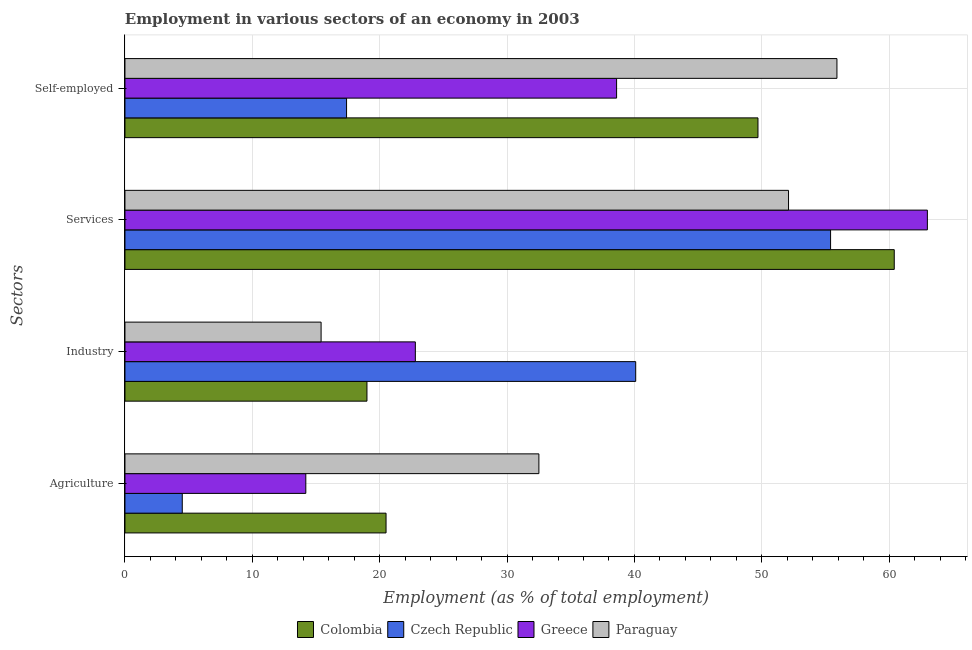Are the number of bars on each tick of the Y-axis equal?
Offer a terse response. Yes. How many bars are there on the 3rd tick from the bottom?
Give a very brief answer. 4. What is the label of the 3rd group of bars from the top?
Your answer should be compact. Industry. What is the percentage of self employed workers in Colombia?
Your answer should be very brief. 49.7. Across all countries, what is the maximum percentage of workers in agriculture?
Give a very brief answer. 32.5. Across all countries, what is the minimum percentage of workers in services?
Your answer should be very brief. 52.1. In which country was the percentage of workers in industry minimum?
Provide a short and direct response. Paraguay. What is the total percentage of workers in agriculture in the graph?
Your answer should be compact. 71.7. What is the difference between the percentage of workers in industry in Colombia and that in Paraguay?
Your answer should be very brief. 3.6. What is the difference between the percentage of workers in agriculture in Colombia and the percentage of workers in industry in Czech Republic?
Make the answer very short. -19.6. What is the average percentage of self employed workers per country?
Give a very brief answer. 40.4. What is the difference between the percentage of self employed workers and percentage of workers in agriculture in Czech Republic?
Offer a terse response. 12.9. In how many countries, is the percentage of workers in industry greater than 50 %?
Your answer should be very brief. 0. What is the ratio of the percentage of workers in agriculture in Czech Republic to that in Paraguay?
Provide a succinct answer. 0.14. Is the percentage of self employed workers in Paraguay less than that in Czech Republic?
Keep it short and to the point. No. What is the difference between the highest and the second highest percentage of self employed workers?
Ensure brevity in your answer.  6.2. What is the difference between the highest and the lowest percentage of workers in services?
Give a very brief answer. 10.9. Is it the case that in every country, the sum of the percentage of workers in services and percentage of workers in industry is greater than the sum of percentage of self employed workers and percentage of workers in agriculture?
Make the answer very short. Yes. What does the 3rd bar from the top in Agriculture represents?
Your answer should be very brief. Czech Republic. What does the 4th bar from the bottom in Agriculture represents?
Your answer should be compact. Paraguay. Is it the case that in every country, the sum of the percentage of workers in agriculture and percentage of workers in industry is greater than the percentage of workers in services?
Give a very brief answer. No. What is the difference between two consecutive major ticks on the X-axis?
Provide a succinct answer. 10. Does the graph contain any zero values?
Ensure brevity in your answer.  No. Does the graph contain grids?
Your response must be concise. Yes. What is the title of the graph?
Keep it short and to the point. Employment in various sectors of an economy in 2003. Does "Thailand" appear as one of the legend labels in the graph?
Offer a terse response. No. What is the label or title of the X-axis?
Ensure brevity in your answer.  Employment (as % of total employment). What is the label or title of the Y-axis?
Offer a terse response. Sectors. What is the Employment (as % of total employment) of Czech Republic in Agriculture?
Make the answer very short. 4.5. What is the Employment (as % of total employment) in Greece in Agriculture?
Your answer should be very brief. 14.2. What is the Employment (as % of total employment) in Paraguay in Agriculture?
Make the answer very short. 32.5. What is the Employment (as % of total employment) of Czech Republic in Industry?
Provide a short and direct response. 40.1. What is the Employment (as % of total employment) in Greece in Industry?
Provide a short and direct response. 22.8. What is the Employment (as % of total employment) in Paraguay in Industry?
Offer a terse response. 15.4. What is the Employment (as % of total employment) in Colombia in Services?
Give a very brief answer. 60.4. What is the Employment (as % of total employment) of Czech Republic in Services?
Ensure brevity in your answer.  55.4. What is the Employment (as % of total employment) in Greece in Services?
Your answer should be compact. 63. What is the Employment (as % of total employment) of Paraguay in Services?
Give a very brief answer. 52.1. What is the Employment (as % of total employment) in Colombia in Self-employed?
Your answer should be compact. 49.7. What is the Employment (as % of total employment) in Czech Republic in Self-employed?
Make the answer very short. 17.4. What is the Employment (as % of total employment) in Greece in Self-employed?
Offer a terse response. 38.6. What is the Employment (as % of total employment) in Paraguay in Self-employed?
Offer a very short reply. 55.9. Across all Sectors, what is the maximum Employment (as % of total employment) in Colombia?
Keep it short and to the point. 60.4. Across all Sectors, what is the maximum Employment (as % of total employment) in Czech Republic?
Provide a succinct answer. 55.4. Across all Sectors, what is the maximum Employment (as % of total employment) of Greece?
Make the answer very short. 63. Across all Sectors, what is the maximum Employment (as % of total employment) of Paraguay?
Provide a succinct answer. 55.9. Across all Sectors, what is the minimum Employment (as % of total employment) of Colombia?
Give a very brief answer. 19. Across all Sectors, what is the minimum Employment (as % of total employment) of Greece?
Provide a short and direct response. 14.2. Across all Sectors, what is the minimum Employment (as % of total employment) of Paraguay?
Provide a short and direct response. 15.4. What is the total Employment (as % of total employment) of Colombia in the graph?
Give a very brief answer. 149.6. What is the total Employment (as % of total employment) of Czech Republic in the graph?
Offer a very short reply. 117.4. What is the total Employment (as % of total employment) in Greece in the graph?
Make the answer very short. 138.6. What is the total Employment (as % of total employment) in Paraguay in the graph?
Give a very brief answer. 155.9. What is the difference between the Employment (as % of total employment) of Colombia in Agriculture and that in Industry?
Provide a short and direct response. 1.5. What is the difference between the Employment (as % of total employment) in Czech Republic in Agriculture and that in Industry?
Provide a succinct answer. -35.6. What is the difference between the Employment (as % of total employment) of Greece in Agriculture and that in Industry?
Provide a short and direct response. -8.6. What is the difference between the Employment (as % of total employment) of Colombia in Agriculture and that in Services?
Offer a very short reply. -39.9. What is the difference between the Employment (as % of total employment) in Czech Republic in Agriculture and that in Services?
Ensure brevity in your answer.  -50.9. What is the difference between the Employment (as % of total employment) in Greece in Agriculture and that in Services?
Your answer should be very brief. -48.8. What is the difference between the Employment (as % of total employment) in Paraguay in Agriculture and that in Services?
Offer a very short reply. -19.6. What is the difference between the Employment (as % of total employment) in Colombia in Agriculture and that in Self-employed?
Your response must be concise. -29.2. What is the difference between the Employment (as % of total employment) in Greece in Agriculture and that in Self-employed?
Your answer should be very brief. -24.4. What is the difference between the Employment (as % of total employment) of Paraguay in Agriculture and that in Self-employed?
Your response must be concise. -23.4. What is the difference between the Employment (as % of total employment) of Colombia in Industry and that in Services?
Provide a succinct answer. -41.4. What is the difference between the Employment (as % of total employment) in Czech Republic in Industry and that in Services?
Your answer should be compact. -15.3. What is the difference between the Employment (as % of total employment) in Greece in Industry and that in Services?
Ensure brevity in your answer.  -40.2. What is the difference between the Employment (as % of total employment) of Paraguay in Industry and that in Services?
Provide a short and direct response. -36.7. What is the difference between the Employment (as % of total employment) of Colombia in Industry and that in Self-employed?
Make the answer very short. -30.7. What is the difference between the Employment (as % of total employment) of Czech Republic in Industry and that in Self-employed?
Ensure brevity in your answer.  22.7. What is the difference between the Employment (as % of total employment) of Greece in Industry and that in Self-employed?
Your answer should be very brief. -15.8. What is the difference between the Employment (as % of total employment) of Paraguay in Industry and that in Self-employed?
Your answer should be compact. -40.5. What is the difference between the Employment (as % of total employment) of Colombia in Services and that in Self-employed?
Offer a terse response. 10.7. What is the difference between the Employment (as % of total employment) in Czech Republic in Services and that in Self-employed?
Your answer should be very brief. 38. What is the difference between the Employment (as % of total employment) in Greece in Services and that in Self-employed?
Give a very brief answer. 24.4. What is the difference between the Employment (as % of total employment) in Paraguay in Services and that in Self-employed?
Give a very brief answer. -3.8. What is the difference between the Employment (as % of total employment) in Colombia in Agriculture and the Employment (as % of total employment) in Czech Republic in Industry?
Provide a succinct answer. -19.6. What is the difference between the Employment (as % of total employment) in Colombia in Agriculture and the Employment (as % of total employment) in Greece in Industry?
Make the answer very short. -2.3. What is the difference between the Employment (as % of total employment) of Czech Republic in Agriculture and the Employment (as % of total employment) of Greece in Industry?
Your answer should be compact. -18.3. What is the difference between the Employment (as % of total employment) of Colombia in Agriculture and the Employment (as % of total employment) of Czech Republic in Services?
Provide a short and direct response. -34.9. What is the difference between the Employment (as % of total employment) of Colombia in Agriculture and the Employment (as % of total employment) of Greece in Services?
Your answer should be very brief. -42.5. What is the difference between the Employment (as % of total employment) of Colombia in Agriculture and the Employment (as % of total employment) of Paraguay in Services?
Provide a short and direct response. -31.6. What is the difference between the Employment (as % of total employment) of Czech Republic in Agriculture and the Employment (as % of total employment) of Greece in Services?
Provide a short and direct response. -58.5. What is the difference between the Employment (as % of total employment) of Czech Republic in Agriculture and the Employment (as % of total employment) of Paraguay in Services?
Keep it short and to the point. -47.6. What is the difference between the Employment (as % of total employment) of Greece in Agriculture and the Employment (as % of total employment) of Paraguay in Services?
Make the answer very short. -37.9. What is the difference between the Employment (as % of total employment) in Colombia in Agriculture and the Employment (as % of total employment) in Greece in Self-employed?
Offer a terse response. -18.1. What is the difference between the Employment (as % of total employment) in Colombia in Agriculture and the Employment (as % of total employment) in Paraguay in Self-employed?
Offer a terse response. -35.4. What is the difference between the Employment (as % of total employment) in Czech Republic in Agriculture and the Employment (as % of total employment) in Greece in Self-employed?
Your response must be concise. -34.1. What is the difference between the Employment (as % of total employment) of Czech Republic in Agriculture and the Employment (as % of total employment) of Paraguay in Self-employed?
Give a very brief answer. -51.4. What is the difference between the Employment (as % of total employment) of Greece in Agriculture and the Employment (as % of total employment) of Paraguay in Self-employed?
Your response must be concise. -41.7. What is the difference between the Employment (as % of total employment) of Colombia in Industry and the Employment (as % of total employment) of Czech Republic in Services?
Ensure brevity in your answer.  -36.4. What is the difference between the Employment (as % of total employment) of Colombia in Industry and the Employment (as % of total employment) of Greece in Services?
Offer a very short reply. -44. What is the difference between the Employment (as % of total employment) in Colombia in Industry and the Employment (as % of total employment) in Paraguay in Services?
Provide a short and direct response. -33.1. What is the difference between the Employment (as % of total employment) of Czech Republic in Industry and the Employment (as % of total employment) of Greece in Services?
Ensure brevity in your answer.  -22.9. What is the difference between the Employment (as % of total employment) in Greece in Industry and the Employment (as % of total employment) in Paraguay in Services?
Your answer should be very brief. -29.3. What is the difference between the Employment (as % of total employment) in Colombia in Industry and the Employment (as % of total employment) in Czech Republic in Self-employed?
Keep it short and to the point. 1.6. What is the difference between the Employment (as % of total employment) of Colombia in Industry and the Employment (as % of total employment) of Greece in Self-employed?
Your answer should be very brief. -19.6. What is the difference between the Employment (as % of total employment) in Colombia in Industry and the Employment (as % of total employment) in Paraguay in Self-employed?
Your response must be concise. -36.9. What is the difference between the Employment (as % of total employment) in Czech Republic in Industry and the Employment (as % of total employment) in Paraguay in Self-employed?
Offer a terse response. -15.8. What is the difference between the Employment (as % of total employment) of Greece in Industry and the Employment (as % of total employment) of Paraguay in Self-employed?
Make the answer very short. -33.1. What is the difference between the Employment (as % of total employment) in Colombia in Services and the Employment (as % of total employment) in Czech Republic in Self-employed?
Your response must be concise. 43. What is the difference between the Employment (as % of total employment) in Colombia in Services and the Employment (as % of total employment) in Greece in Self-employed?
Provide a short and direct response. 21.8. What is the difference between the Employment (as % of total employment) of Czech Republic in Services and the Employment (as % of total employment) of Greece in Self-employed?
Keep it short and to the point. 16.8. What is the difference between the Employment (as % of total employment) of Greece in Services and the Employment (as % of total employment) of Paraguay in Self-employed?
Your answer should be very brief. 7.1. What is the average Employment (as % of total employment) of Colombia per Sectors?
Give a very brief answer. 37.4. What is the average Employment (as % of total employment) of Czech Republic per Sectors?
Offer a very short reply. 29.35. What is the average Employment (as % of total employment) in Greece per Sectors?
Your answer should be very brief. 34.65. What is the average Employment (as % of total employment) in Paraguay per Sectors?
Ensure brevity in your answer.  38.98. What is the difference between the Employment (as % of total employment) in Colombia and Employment (as % of total employment) in Greece in Agriculture?
Give a very brief answer. 6.3. What is the difference between the Employment (as % of total employment) in Czech Republic and Employment (as % of total employment) in Paraguay in Agriculture?
Your answer should be very brief. -28. What is the difference between the Employment (as % of total employment) in Greece and Employment (as % of total employment) in Paraguay in Agriculture?
Offer a very short reply. -18.3. What is the difference between the Employment (as % of total employment) in Colombia and Employment (as % of total employment) in Czech Republic in Industry?
Keep it short and to the point. -21.1. What is the difference between the Employment (as % of total employment) in Colombia and Employment (as % of total employment) in Paraguay in Industry?
Your answer should be very brief. 3.6. What is the difference between the Employment (as % of total employment) of Czech Republic and Employment (as % of total employment) of Greece in Industry?
Ensure brevity in your answer.  17.3. What is the difference between the Employment (as % of total employment) of Czech Republic and Employment (as % of total employment) of Paraguay in Industry?
Give a very brief answer. 24.7. What is the difference between the Employment (as % of total employment) of Greece and Employment (as % of total employment) of Paraguay in Industry?
Make the answer very short. 7.4. What is the difference between the Employment (as % of total employment) in Colombia and Employment (as % of total employment) in Czech Republic in Services?
Provide a succinct answer. 5. What is the difference between the Employment (as % of total employment) in Colombia and Employment (as % of total employment) in Greece in Services?
Ensure brevity in your answer.  -2.6. What is the difference between the Employment (as % of total employment) of Czech Republic and Employment (as % of total employment) of Greece in Services?
Keep it short and to the point. -7.6. What is the difference between the Employment (as % of total employment) of Greece and Employment (as % of total employment) of Paraguay in Services?
Give a very brief answer. 10.9. What is the difference between the Employment (as % of total employment) of Colombia and Employment (as % of total employment) of Czech Republic in Self-employed?
Give a very brief answer. 32.3. What is the difference between the Employment (as % of total employment) of Czech Republic and Employment (as % of total employment) of Greece in Self-employed?
Your answer should be very brief. -21.2. What is the difference between the Employment (as % of total employment) of Czech Republic and Employment (as % of total employment) of Paraguay in Self-employed?
Provide a short and direct response. -38.5. What is the difference between the Employment (as % of total employment) of Greece and Employment (as % of total employment) of Paraguay in Self-employed?
Your response must be concise. -17.3. What is the ratio of the Employment (as % of total employment) of Colombia in Agriculture to that in Industry?
Make the answer very short. 1.08. What is the ratio of the Employment (as % of total employment) in Czech Republic in Agriculture to that in Industry?
Provide a short and direct response. 0.11. What is the ratio of the Employment (as % of total employment) of Greece in Agriculture to that in Industry?
Provide a succinct answer. 0.62. What is the ratio of the Employment (as % of total employment) in Paraguay in Agriculture to that in Industry?
Make the answer very short. 2.11. What is the ratio of the Employment (as % of total employment) of Colombia in Agriculture to that in Services?
Make the answer very short. 0.34. What is the ratio of the Employment (as % of total employment) in Czech Republic in Agriculture to that in Services?
Provide a succinct answer. 0.08. What is the ratio of the Employment (as % of total employment) of Greece in Agriculture to that in Services?
Give a very brief answer. 0.23. What is the ratio of the Employment (as % of total employment) of Paraguay in Agriculture to that in Services?
Your response must be concise. 0.62. What is the ratio of the Employment (as % of total employment) of Colombia in Agriculture to that in Self-employed?
Your answer should be compact. 0.41. What is the ratio of the Employment (as % of total employment) in Czech Republic in Agriculture to that in Self-employed?
Offer a terse response. 0.26. What is the ratio of the Employment (as % of total employment) of Greece in Agriculture to that in Self-employed?
Offer a very short reply. 0.37. What is the ratio of the Employment (as % of total employment) of Paraguay in Agriculture to that in Self-employed?
Your answer should be very brief. 0.58. What is the ratio of the Employment (as % of total employment) of Colombia in Industry to that in Services?
Ensure brevity in your answer.  0.31. What is the ratio of the Employment (as % of total employment) in Czech Republic in Industry to that in Services?
Offer a terse response. 0.72. What is the ratio of the Employment (as % of total employment) in Greece in Industry to that in Services?
Your answer should be very brief. 0.36. What is the ratio of the Employment (as % of total employment) in Paraguay in Industry to that in Services?
Give a very brief answer. 0.3. What is the ratio of the Employment (as % of total employment) in Colombia in Industry to that in Self-employed?
Your answer should be very brief. 0.38. What is the ratio of the Employment (as % of total employment) in Czech Republic in Industry to that in Self-employed?
Make the answer very short. 2.3. What is the ratio of the Employment (as % of total employment) of Greece in Industry to that in Self-employed?
Keep it short and to the point. 0.59. What is the ratio of the Employment (as % of total employment) of Paraguay in Industry to that in Self-employed?
Ensure brevity in your answer.  0.28. What is the ratio of the Employment (as % of total employment) of Colombia in Services to that in Self-employed?
Your response must be concise. 1.22. What is the ratio of the Employment (as % of total employment) in Czech Republic in Services to that in Self-employed?
Offer a terse response. 3.18. What is the ratio of the Employment (as % of total employment) of Greece in Services to that in Self-employed?
Offer a terse response. 1.63. What is the ratio of the Employment (as % of total employment) of Paraguay in Services to that in Self-employed?
Provide a short and direct response. 0.93. What is the difference between the highest and the second highest Employment (as % of total employment) in Colombia?
Keep it short and to the point. 10.7. What is the difference between the highest and the second highest Employment (as % of total employment) in Greece?
Your answer should be compact. 24.4. What is the difference between the highest and the lowest Employment (as % of total employment) of Colombia?
Offer a very short reply. 41.4. What is the difference between the highest and the lowest Employment (as % of total employment) in Czech Republic?
Make the answer very short. 50.9. What is the difference between the highest and the lowest Employment (as % of total employment) in Greece?
Your answer should be very brief. 48.8. What is the difference between the highest and the lowest Employment (as % of total employment) in Paraguay?
Offer a terse response. 40.5. 